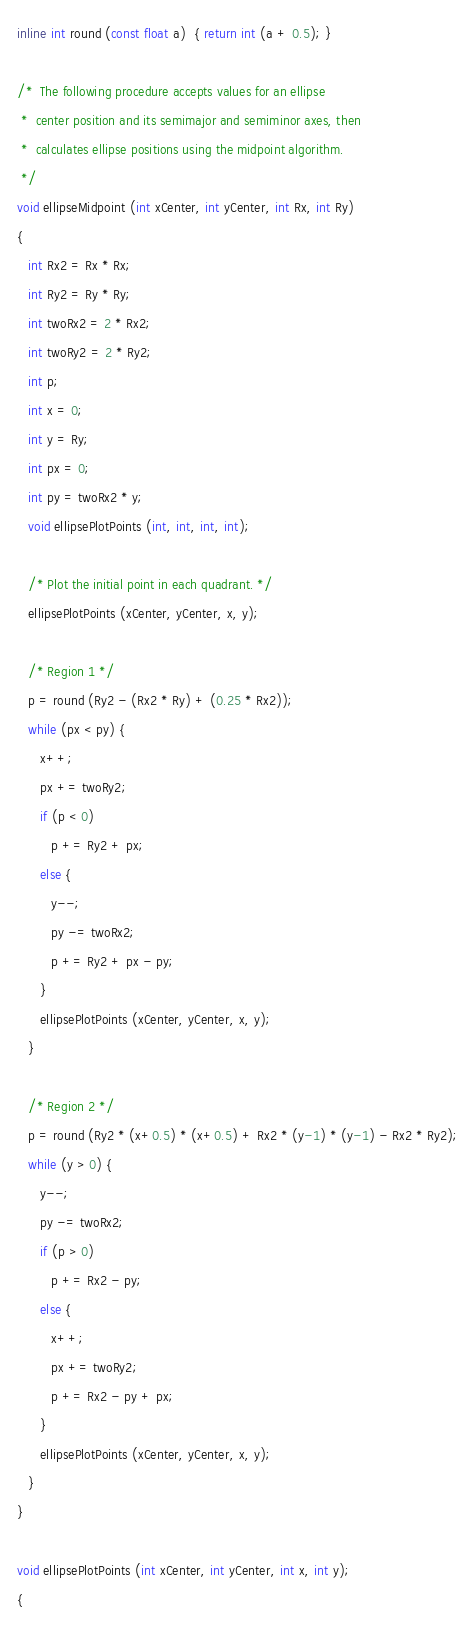<code> <loc_0><loc_0><loc_500><loc_500><_C++_>inline int round (const float a)  { return int (a + 0.5); }

/*  The following procedure accepts values for an ellipse
 *  center position and its semimajor and semiminor axes, then 
 *  calculates ellipse positions using the midpoint algorithm.
 */  
void ellipseMidpoint (int xCenter, int yCenter, int Rx, int Ry)
{
   int Rx2 = Rx * Rx;
   int Ry2 = Ry * Ry;
   int twoRx2 = 2 * Rx2;
   int twoRy2 = 2 * Ry2;
   int p;
   int x = 0;
   int y = Ry;
   int px = 0;
   int py = twoRx2 * y;
   void ellipsePlotPoints (int, int, int, int);

   /* Plot the initial point in each quadrant. */
   ellipsePlotPoints (xCenter, yCenter, x, y);

   /* Region 1 */
   p = round (Ry2 - (Rx2 * Ry) + (0.25 * Rx2));
   while (px < py) {
      x++;
      px += twoRy2;
      if (p < 0)
         p += Ry2 + px;
      else {
         y--;
         py -= twoRx2;
         p += Ry2 + px - py;
      }
      ellipsePlotPoints (xCenter, yCenter, x, y);
   }

   /* Region 2 */
   p = round (Ry2 * (x+0.5) * (x+0.5) + Rx2 * (y-1) * (y-1) - Rx2 * Ry2);
   while (y > 0) {
      y--;
      py -= twoRx2;
      if (p > 0)
         p += Rx2 - py;
      else {
         x++;
         px += twoRy2;
         p += Rx2 - py + px;
      }
      ellipsePlotPoints (xCenter, yCenter, x, y);
   }
}

void ellipsePlotPoints (int xCenter, int yCenter, int x, int y);
{</code> 